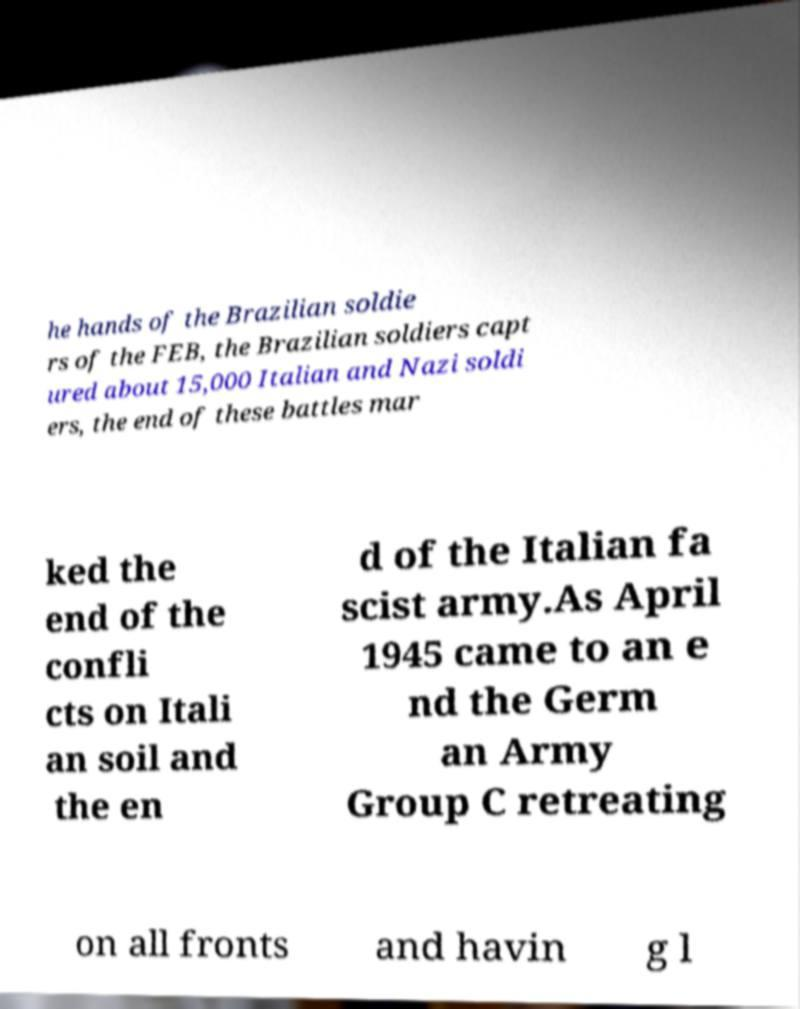What messages or text are displayed in this image? I need them in a readable, typed format. he hands of the Brazilian soldie rs of the FEB, the Brazilian soldiers capt ured about 15,000 Italian and Nazi soldi ers, the end of these battles mar ked the end of the confli cts on Itali an soil and the en d of the Italian fa scist army.As April 1945 came to an e nd the Germ an Army Group C retreating on all fronts and havin g l 